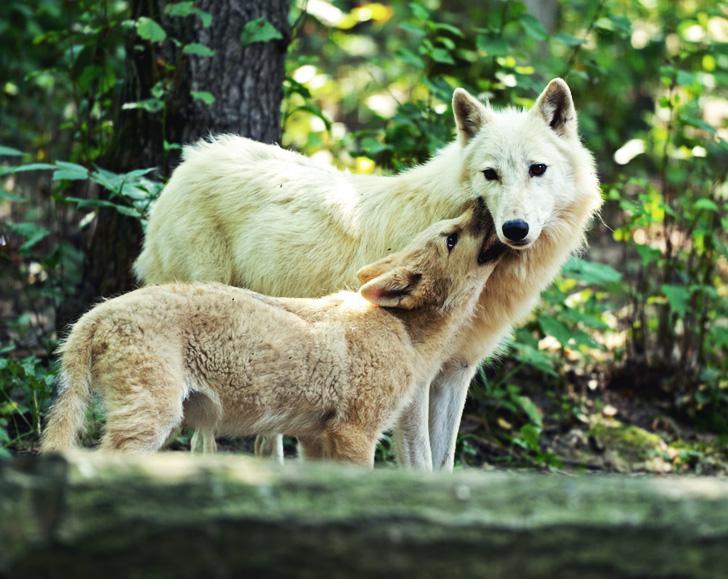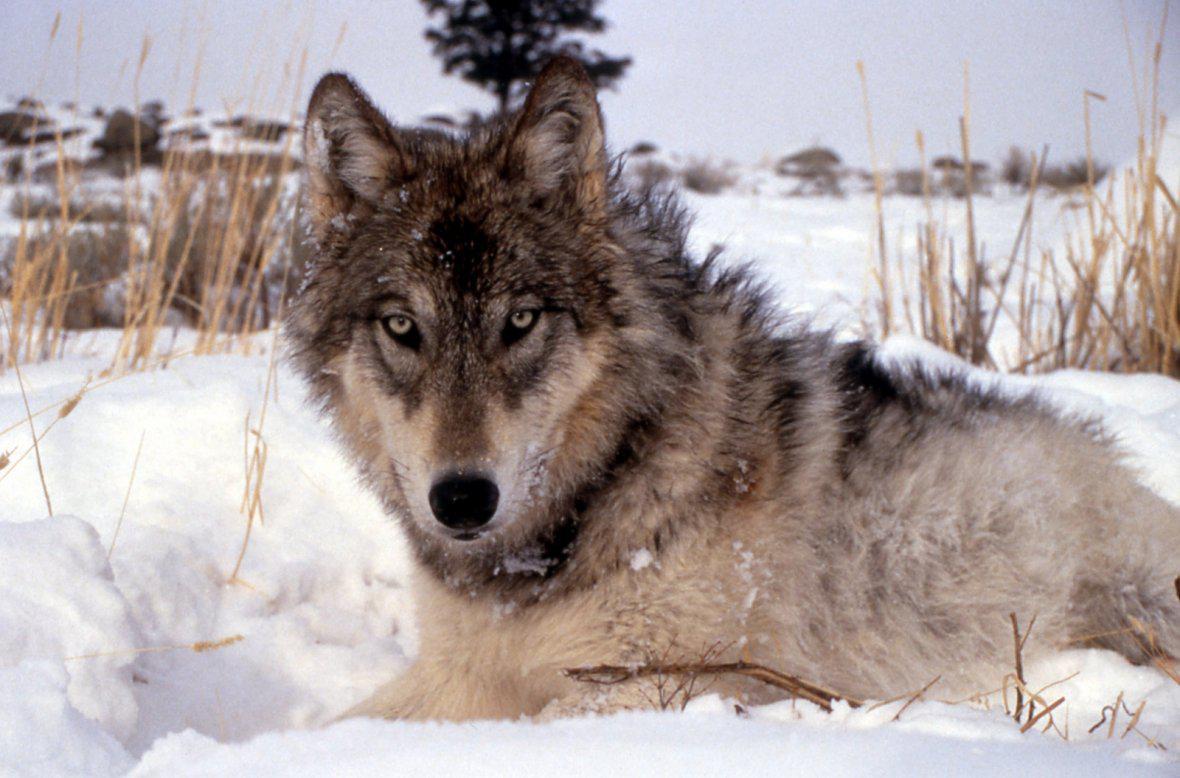The first image is the image on the left, the second image is the image on the right. For the images shown, is this caption "At least one wolf is hovering over dead prey." true? Answer yes or no. No. 